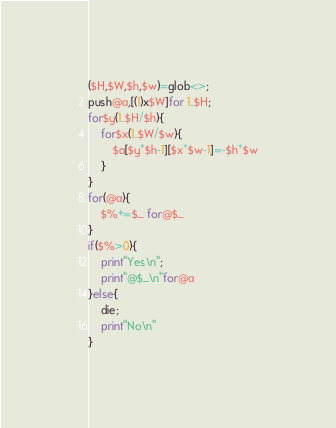<code> <loc_0><loc_0><loc_500><loc_500><_Perl_>($H,$W,$h,$w)=glob<>;
push@a,[(1)x$W]for 1..$H;
for$y(1..$H/$h){
	for$x(1..$W/$w){
		$a[$y*$h-1][$x*$w-1]=-$h*$w
	}
}
for(@a){
	$%+=$_ for@$_
}
if($%>0){
	print"Yes\n";
	print"@$_\n"for@a
}else{
	die;
	print"No\n"
}
</code> 